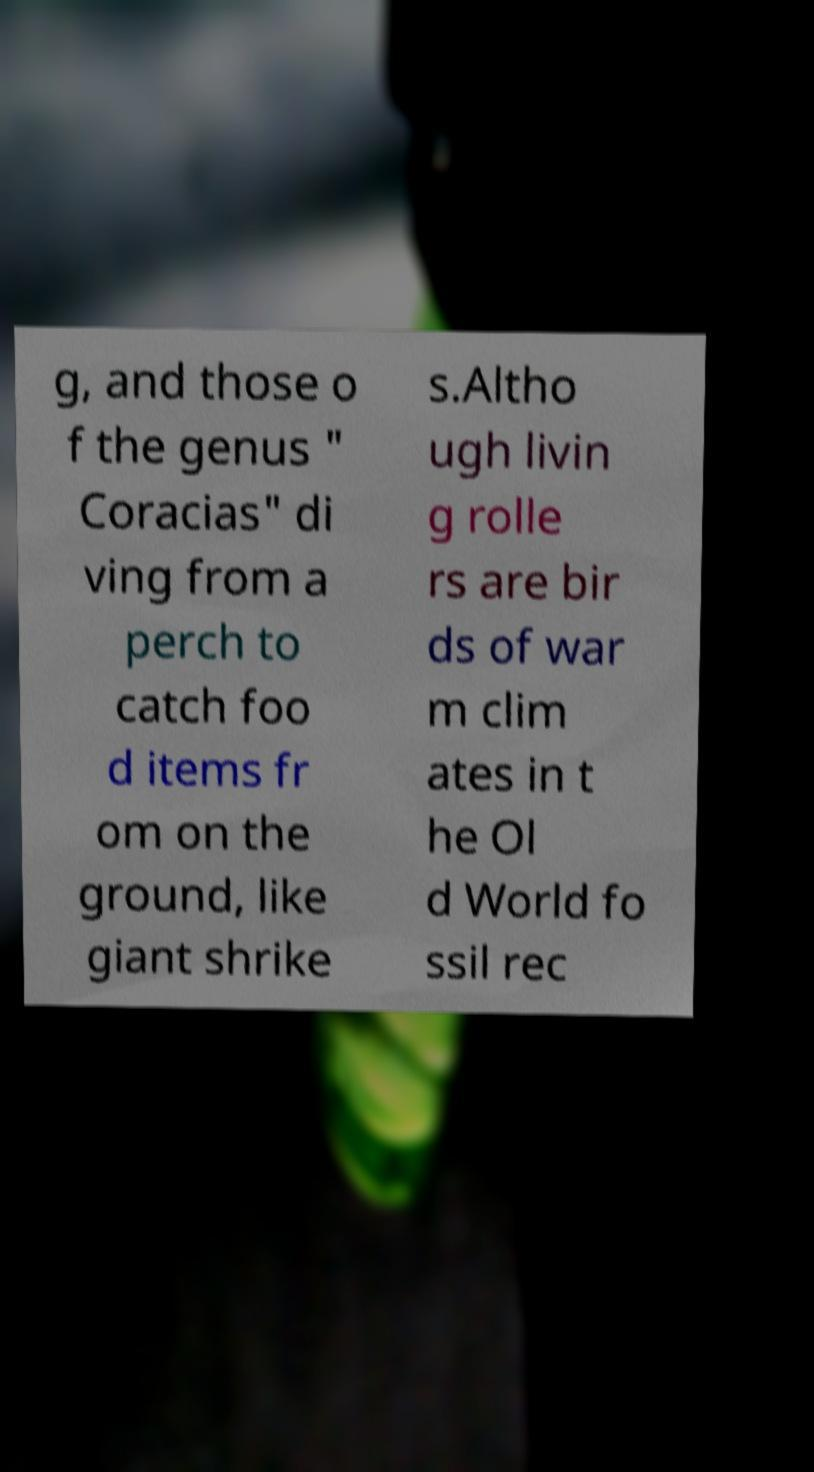Could you extract and type out the text from this image? g, and those o f the genus " Coracias" di ving from a perch to catch foo d items fr om on the ground, like giant shrike s.Altho ugh livin g rolle rs are bir ds of war m clim ates in t he Ol d World fo ssil rec 